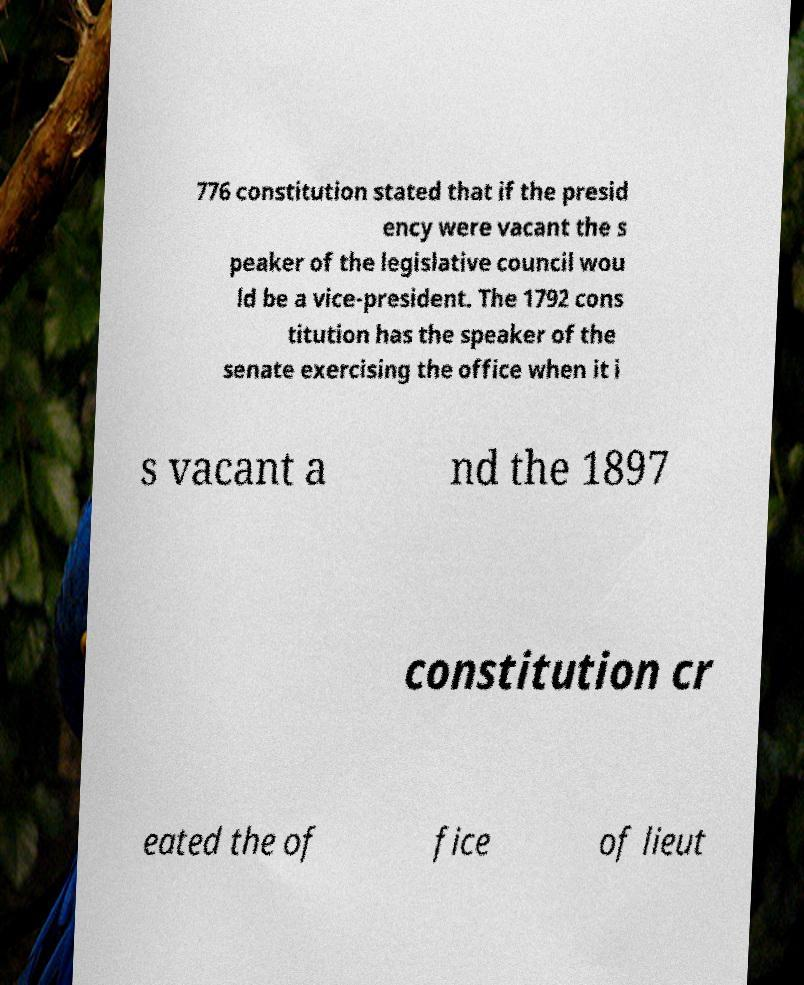Can you accurately transcribe the text from the provided image for me? 776 constitution stated that if the presid ency were vacant the s peaker of the legislative council wou ld be a vice-president. The 1792 cons titution has the speaker of the senate exercising the office when it i s vacant a nd the 1897 constitution cr eated the of fice of lieut 